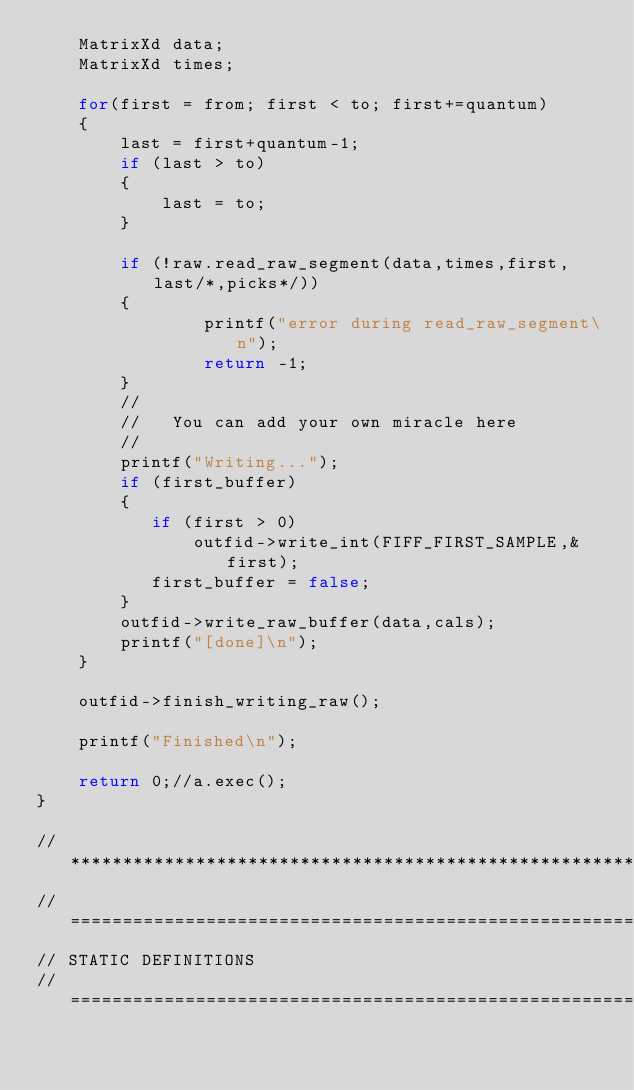Convert code to text. <code><loc_0><loc_0><loc_500><loc_500><_C++_>    MatrixXd data;
    MatrixXd times;

    for(first = from; first < to; first+=quantum)
    {
        last = first+quantum-1;
        if (last > to)
        {
            last = to;
        }

        if (!raw.read_raw_segment(data,times,first,last/*,picks*/))
        {
                printf("error during read_raw_segment\n");
                return -1;
        }
        //
        //   You can add your own miracle here
        //
        printf("Writing...");
        if (first_buffer)
        {
           if (first > 0)
               outfid->write_int(FIFF_FIRST_SAMPLE,&first);
           first_buffer = false;
        }
        outfid->write_raw_buffer(data,cals);
        printf("[done]\n");
    }

    outfid->finish_writing_raw();

    printf("Finished\n");

    return 0;//a.exec();
}

//*************************************************************************************************************
//=============================================================================================================
// STATIC DEFINITIONS
//=============================================================================================================


</code> 